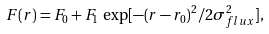<formula> <loc_0><loc_0><loc_500><loc_500>F ( r ) = F _ { 0 } + F _ { 1 } \, \exp [ - ( r - r _ { 0 } ) ^ { 2 } / 2 \sigma _ { f l u x } ^ { 2 } ] ,</formula> 